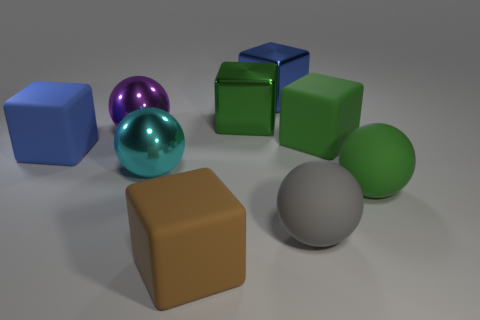How many big objects are both right of the green metal object and behind the large purple metal thing? There is one large object to the right of the green metal sphere and behind the large purple metal sphere; it is a blue cube. 